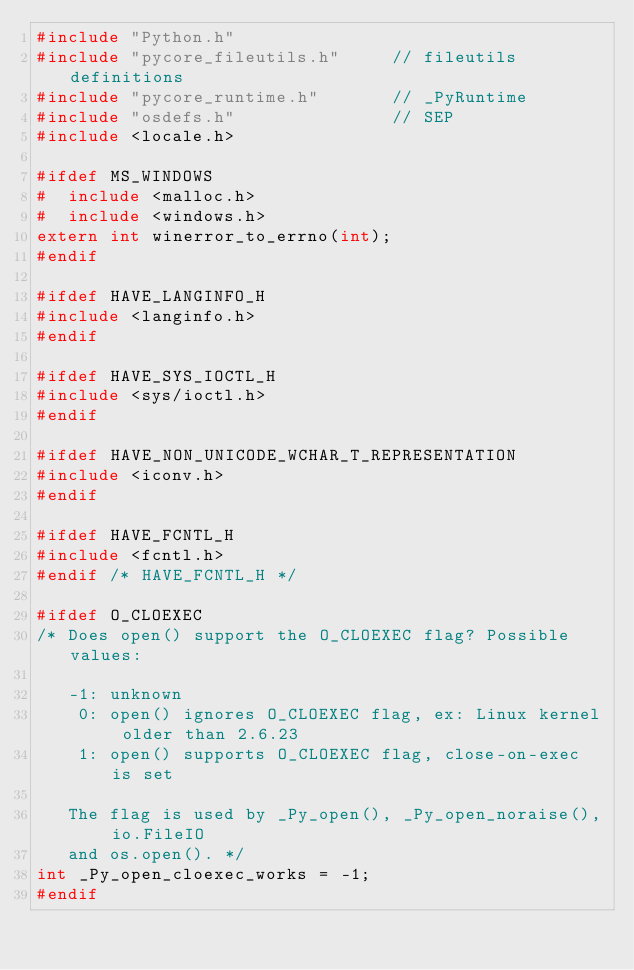<code> <loc_0><loc_0><loc_500><loc_500><_C_>#include "Python.h"
#include "pycore_fileutils.h"     // fileutils definitions
#include "pycore_runtime.h"       // _PyRuntime
#include "osdefs.h"               // SEP
#include <locale.h>

#ifdef MS_WINDOWS
#  include <malloc.h>
#  include <windows.h>
extern int winerror_to_errno(int);
#endif

#ifdef HAVE_LANGINFO_H
#include <langinfo.h>
#endif

#ifdef HAVE_SYS_IOCTL_H
#include <sys/ioctl.h>
#endif

#ifdef HAVE_NON_UNICODE_WCHAR_T_REPRESENTATION
#include <iconv.h>
#endif

#ifdef HAVE_FCNTL_H
#include <fcntl.h>
#endif /* HAVE_FCNTL_H */

#ifdef O_CLOEXEC
/* Does open() support the O_CLOEXEC flag? Possible values:

   -1: unknown
    0: open() ignores O_CLOEXEC flag, ex: Linux kernel older than 2.6.23
    1: open() supports O_CLOEXEC flag, close-on-exec is set

   The flag is used by _Py_open(), _Py_open_noraise(), io.FileIO
   and os.open(). */
int _Py_open_cloexec_works = -1;
#endif
</code> 